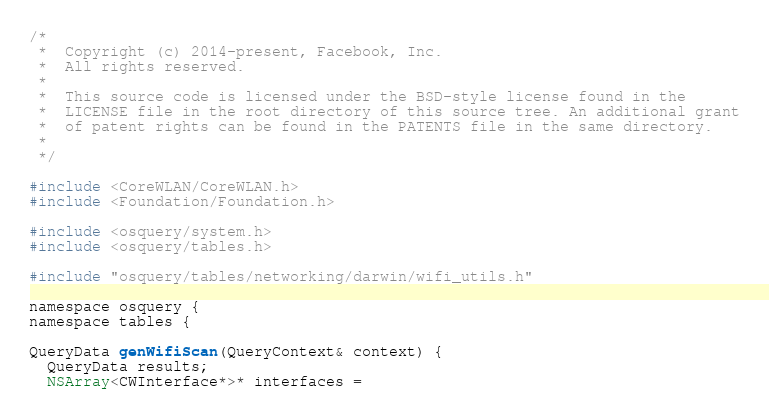<code> <loc_0><loc_0><loc_500><loc_500><_ObjectiveC_>/*
 *  Copyright (c) 2014-present, Facebook, Inc.
 *  All rights reserved.
 *
 *  This source code is licensed under the BSD-style license found in the
 *  LICENSE file in the root directory of this source tree. An additional grant
 *  of patent rights can be found in the PATENTS file in the same directory.
 *
 */

#include <CoreWLAN/CoreWLAN.h>
#include <Foundation/Foundation.h>

#include <osquery/system.h>
#include <osquery/tables.h>

#include "osquery/tables/networking/darwin/wifi_utils.h"

namespace osquery {
namespace tables {

QueryData genWifiScan(QueryContext& context) {
  QueryData results;
  NSArray<CWInterface*>* interfaces =</code> 